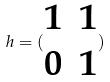<formula> <loc_0><loc_0><loc_500><loc_500>h = ( \begin{matrix} 1 & 1 \\ 0 & 1 \end{matrix} )</formula> 